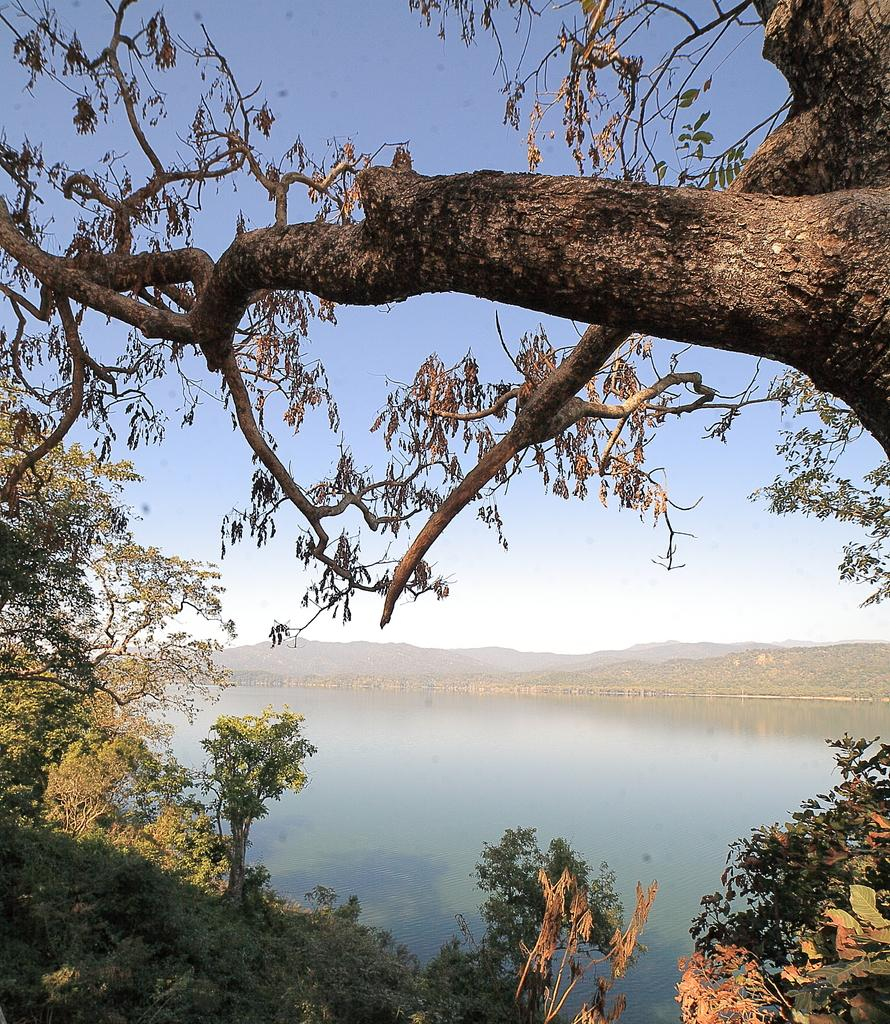What type of vegetation can be seen in the image? There are trees in the image. Where are the trees located in relation to the image? The trees are in front of the image. What is located in the middle of the image? There is water in the middle of the image. What can be seen in the background of the image? The sky is visible in the background of the image. What type of sign can be seen on the sheet in the image? There is no sign or sheet present in the image; it only features trees, water, and the sky. 